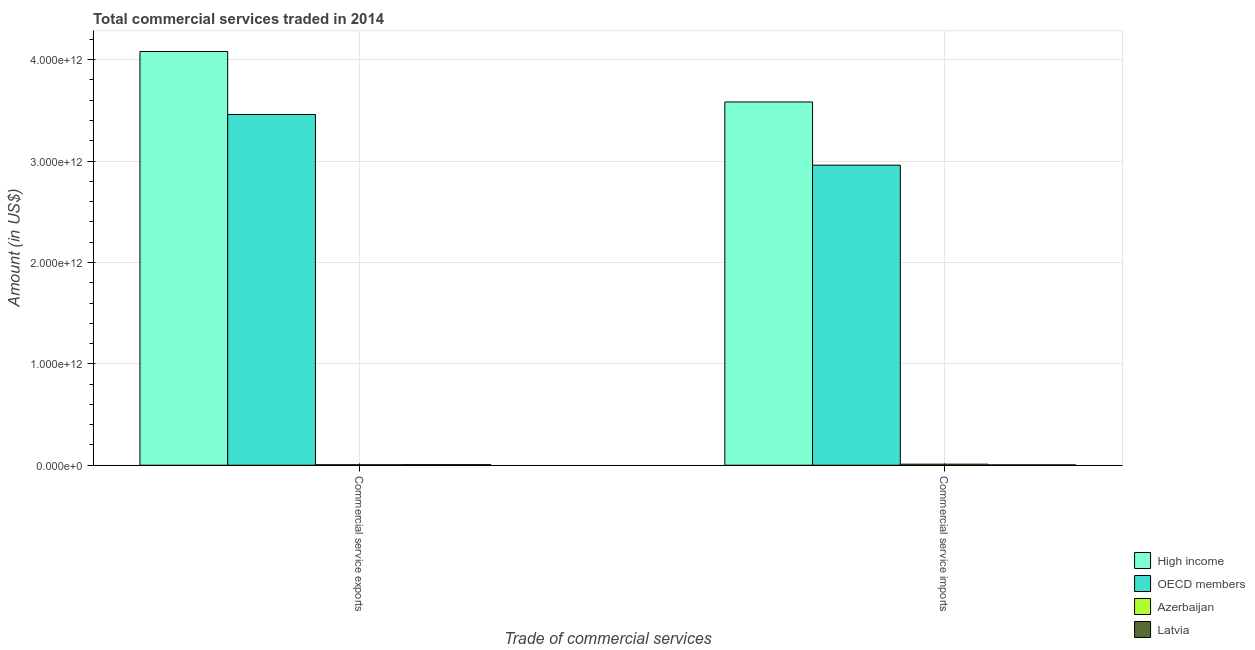Are the number of bars per tick equal to the number of legend labels?
Your answer should be compact. Yes. Are the number of bars on each tick of the X-axis equal?
Keep it short and to the point. Yes. How many bars are there on the 2nd tick from the right?
Offer a terse response. 4. What is the label of the 2nd group of bars from the left?
Your response must be concise. Commercial service imports. What is the amount of commercial service imports in OECD members?
Provide a short and direct response. 2.96e+12. Across all countries, what is the maximum amount of commercial service exports?
Provide a succinct answer. 4.08e+12. Across all countries, what is the minimum amount of commercial service imports?
Give a very brief answer. 2.76e+09. In which country was the amount of commercial service imports minimum?
Offer a very short reply. Latvia. What is the total amount of commercial service imports in the graph?
Your response must be concise. 6.56e+12. What is the difference between the amount of commercial service imports in Latvia and that in Azerbaijan?
Provide a succinct answer. -7.43e+09. What is the difference between the amount of commercial service exports in Azerbaijan and the amount of commercial service imports in High income?
Offer a terse response. -3.58e+12. What is the average amount of commercial service exports per country?
Your answer should be very brief. 1.89e+12. What is the difference between the amount of commercial service exports and amount of commercial service imports in OECD members?
Provide a short and direct response. 5.00e+11. In how many countries, is the amount of commercial service imports greater than 2200000000000 US$?
Offer a terse response. 2. What is the ratio of the amount of commercial service imports in Latvia to that in High income?
Offer a terse response. 0. Is the amount of commercial service imports in Latvia less than that in Azerbaijan?
Make the answer very short. Yes. What does the 1st bar from the left in Commercial service imports represents?
Your response must be concise. High income. Are all the bars in the graph horizontal?
Your answer should be very brief. No. What is the difference between two consecutive major ticks on the Y-axis?
Your response must be concise. 1.00e+12. How many legend labels are there?
Offer a terse response. 4. What is the title of the graph?
Offer a very short reply. Total commercial services traded in 2014. Does "China" appear as one of the legend labels in the graph?
Keep it short and to the point. No. What is the label or title of the X-axis?
Keep it short and to the point. Trade of commercial services. What is the label or title of the Y-axis?
Provide a short and direct response. Amount (in US$). What is the Amount (in US$) in High income in Commercial service exports?
Provide a short and direct response. 4.08e+12. What is the Amount (in US$) of OECD members in Commercial service exports?
Offer a terse response. 3.46e+12. What is the Amount (in US$) in Azerbaijan in Commercial service exports?
Keep it short and to the point. 4.27e+09. What is the Amount (in US$) of Latvia in Commercial service exports?
Provide a succinct answer. 5.05e+09. What is the Amount (in US$) in High income in Commercial service imports?
Your response must be concise. 3.58e+12. What is the Amount (in US$) of OECD members in Commercial service imports?
Give a very brief answer. 2.96e+12. What is the Amount (in US$) in Azerbaijan in Commercial service imports?
Ensure brevity in your answer.  1.02e+1. What is the Amount (in US$) of Latvia in Commercial service imports?
Offer a terse response. 2.76e+09. Across all Trade of commercial services, what is the maximum Amount (in US$) in High income?
Keep it short and to the point. 4.08e+12. Across all Trade of commercial services, what is the maximum Amount (in US$) of OECD members?
Ensure brevity in your answer.  3.46e+12. Across all Trade of commercial services, what is the maximum Amount (in US$) in Azerbaijan?
Your answer should be very brief. 1.02e+1. Across all Trade of commercial services, what is the maximum Amount (in US$) of Latvia?
Provide a short and direct response. 5.05e+09. Across all Trade of commercial services, what is the minimum Amount (in US$) of High income?
Give a very brief answer. 3.58e+12. Across all Trade of commercial services, what is the minimum Amount (in US$) in OECD members?
Offer a terse response. 2.96e+12. Across all Trade of commercial services, what is the minimum Amount (in US$) of Azerbaijan?
Your answer should be very brief. 4.27e+09. Across all Trade of commercial services, what is the minimum Amount (in US$) of Latvia?
Offer a very short reply. 2.76e+09. What is the total Amount (in US$) of High income in the graph?
Ensure brevity in your answer.  7.66e+12. What is the total Amount (in US$) in OECD members in the graph?
Provide a succinct answer. 6.42e+12. What is the total Amount (in US$) of Azerbaijan in the graph?
Your answer should be compact. 1.45e+1. What is the total Amount (in US$) in Latvia in the graph?
Your answer should be very brief. 7.81e+09. What is the difference between the Amount (in US$) in High income in Commercial service exports and that in Commercial service imports?
Your answer should be compact. 4.98e+11. What is the difference between the Amount (in US$) in OECD members in Commercial service exports and that in Commercial service imports?
Your answer should be very brief. 5.00e+11. What is the difference between the Amount (in US$) of Azerbaijan in Commercial service exports and that in Commercial service imports?
Your answer should be compact. -5.92e+09. What is the difference between the Amount (in US$) in Latvia in Commercial service exports and that in Commercial service imports?
Provide a succinct answer. 2.30e+09. What is the difference between the Amount (in US$) of High income in Commercial service exports and the Amount (in US$) of OECD members in Commercial service imports?
Keep it short and to the point. 1.12e+12. What is the difference between the Amount (in US$) in High income in Commercial service exports and the Amount (in US$) in Azerbaijan in Commercial service imports?
Give a very brief answer. 4.07e+12. What is the difference between the Amount (in US$) of High income in Commercial service exports and the Amount (in US$) of Latvia in Commercial service imports?
Offer a terse response. 4.08e+12. What is the difference between the Amount (in US$) of OECD members in Commercial service exports and the Amount (in US$) of Azerbaijan in Commercial service imports?
Your answer should be very brief. 3.45e+12. What is the difference between the Amount (in US$) of OECD members in Commercial service exports and the Amount (in US$) of Latvia in Commercial service imports?
Offer a terse response. 3.46e+12. What is the difference between the Amount (in US$) of Azerbaijan in Commercial service exports and the Amount (in US$) of Latvia in Commercial service imports?
Make the answer very short. 1.51e+09. What is the average Amount (in US$) in High income per Trade of commercial services?
Your response must be concise. 3.83e+12. What is the average Amount (in US$) of OECD members per Trade of commercial services?
Ensure brevity in your answer.  3.21e+12. What is the average Amount (in US$) in Azerbaijan per Trade of commercial services?
Your response must be concise. 7.23e+09. What is the average Amount (in US$) in Latvia per Trade of commercial services?
Give a very brief answer. 3.91e+09. What is the difference between the Amount (in US$) in High income and Amount (in US$) in OECD members in Commercial service exports?
Offer a terse response. 6.21e+11. What is the difference between the Amount (in US$) of High income and Amount (in US$) of Azerbaijan in Commercial service exports?
Your response must be concise. 4.08e+12. What is the difference between the Amount (in US$) in High income and Amount (in US$) in Latvia in Commercial service exports?
Keep it short and to the point. 4.08e+12. What is the difference between the Amount (in US$) of OECD members and Amount (in US$) of Azerbaijan in Commercial service exports?
Keep it short and to the point. 3.46e+12. What is the difference between the Amount (in US$) of OECD members and Amount (in US$) of Latvia in Commercial service exports?
Ensure brevity in your answer.  3.45e+12. What is the difference between the Amount (in US$) in Azerbaijan and Amount (in US$) in Latvia in Commercial service exports?
Offer a terse response. -7.86e+08. What is the difference between the Amount (in US$) in High income and Amount (in US$) in OECD members in Commercial service imports?
Give a very brief answer. 6.24e+11. What is the difference between the Amount (in US$) of High income and Amount (in US$) of Azerbaijan in Commercial service imports?
Offer a very short reply. 3.57e+12. What is the difference between the Amount (in US$) in High income and Amount (in US$) in Latvia in Commercial service imports?
Provide a short and direct response. 3.58e+12. What is the difference between the Amount (in US$) of OECD members and Amount (in US$) of Azerbaijan in Commercial service imports?
Your response must be concise. 2.95e+12. What is the difference between the Amount (in US$) in OECD members and Amount (in US$) in Latvia in Commercial service imports?
Your answer should be compact. 2.96e+12. What is the difference between the Amount (in US$) of Azerbaijan and Amount (in US$) of Latvia in Commercial service imports?
Your answer should be very brief. 7.43e+09. What is the ratio of the Amount (in US$) in High income in Commercial service exports to that in Commercial service imports?
Offer a terse response. 1.14. What is the ratio of the Amount (in US$) in OECD members in Commercial service exports to that in Commercial service imports?
Your answer should be compact. 1.17. What is the ratio of the Amount (in US$) of Azerbaijan in Commercial service exports to that in Commercial service imports?
Your response must be concise. 0.42. What is the ratio of the Amount (in US$) of Latvia in Commercial service exports to that in Commercial service imports?
Ensure brevity in your answer.  1.83. What is the difference between the highest and the second highest Amount (in US$) of High income?
Your answer should be very brief. 4.98e+11. What is the difference between the highest and the second highest Amount (in US$) of OECD members?
Make the answer very short. 5.00e+11. What is the difference between the highest and the second highest Amount (in US$) in Azerbaijan?
Your response must be concise. 5.92e+09. What is the difference between the highest and the second highest Amount (in US$) of Latvia?
Make the answer very short. 2.30e+09. What is the difference between the highest and the lowest Amount (in US$) of High income?
Make the answer very short. 4.98e+11. What is the difference between the highest and the lowest Amount (in US$) in OECD members?
Provide a succinct answer. 5.00e+11. What is the difference between the highest and the lowest Amount (in US$) of Azerbaijan?
Ensure brevity in your answer.  5.92e+09. What is the difference between the highest and the lowest Amount (in US$) of Latvia?
Offer a very short reply. 2.30e+09. 